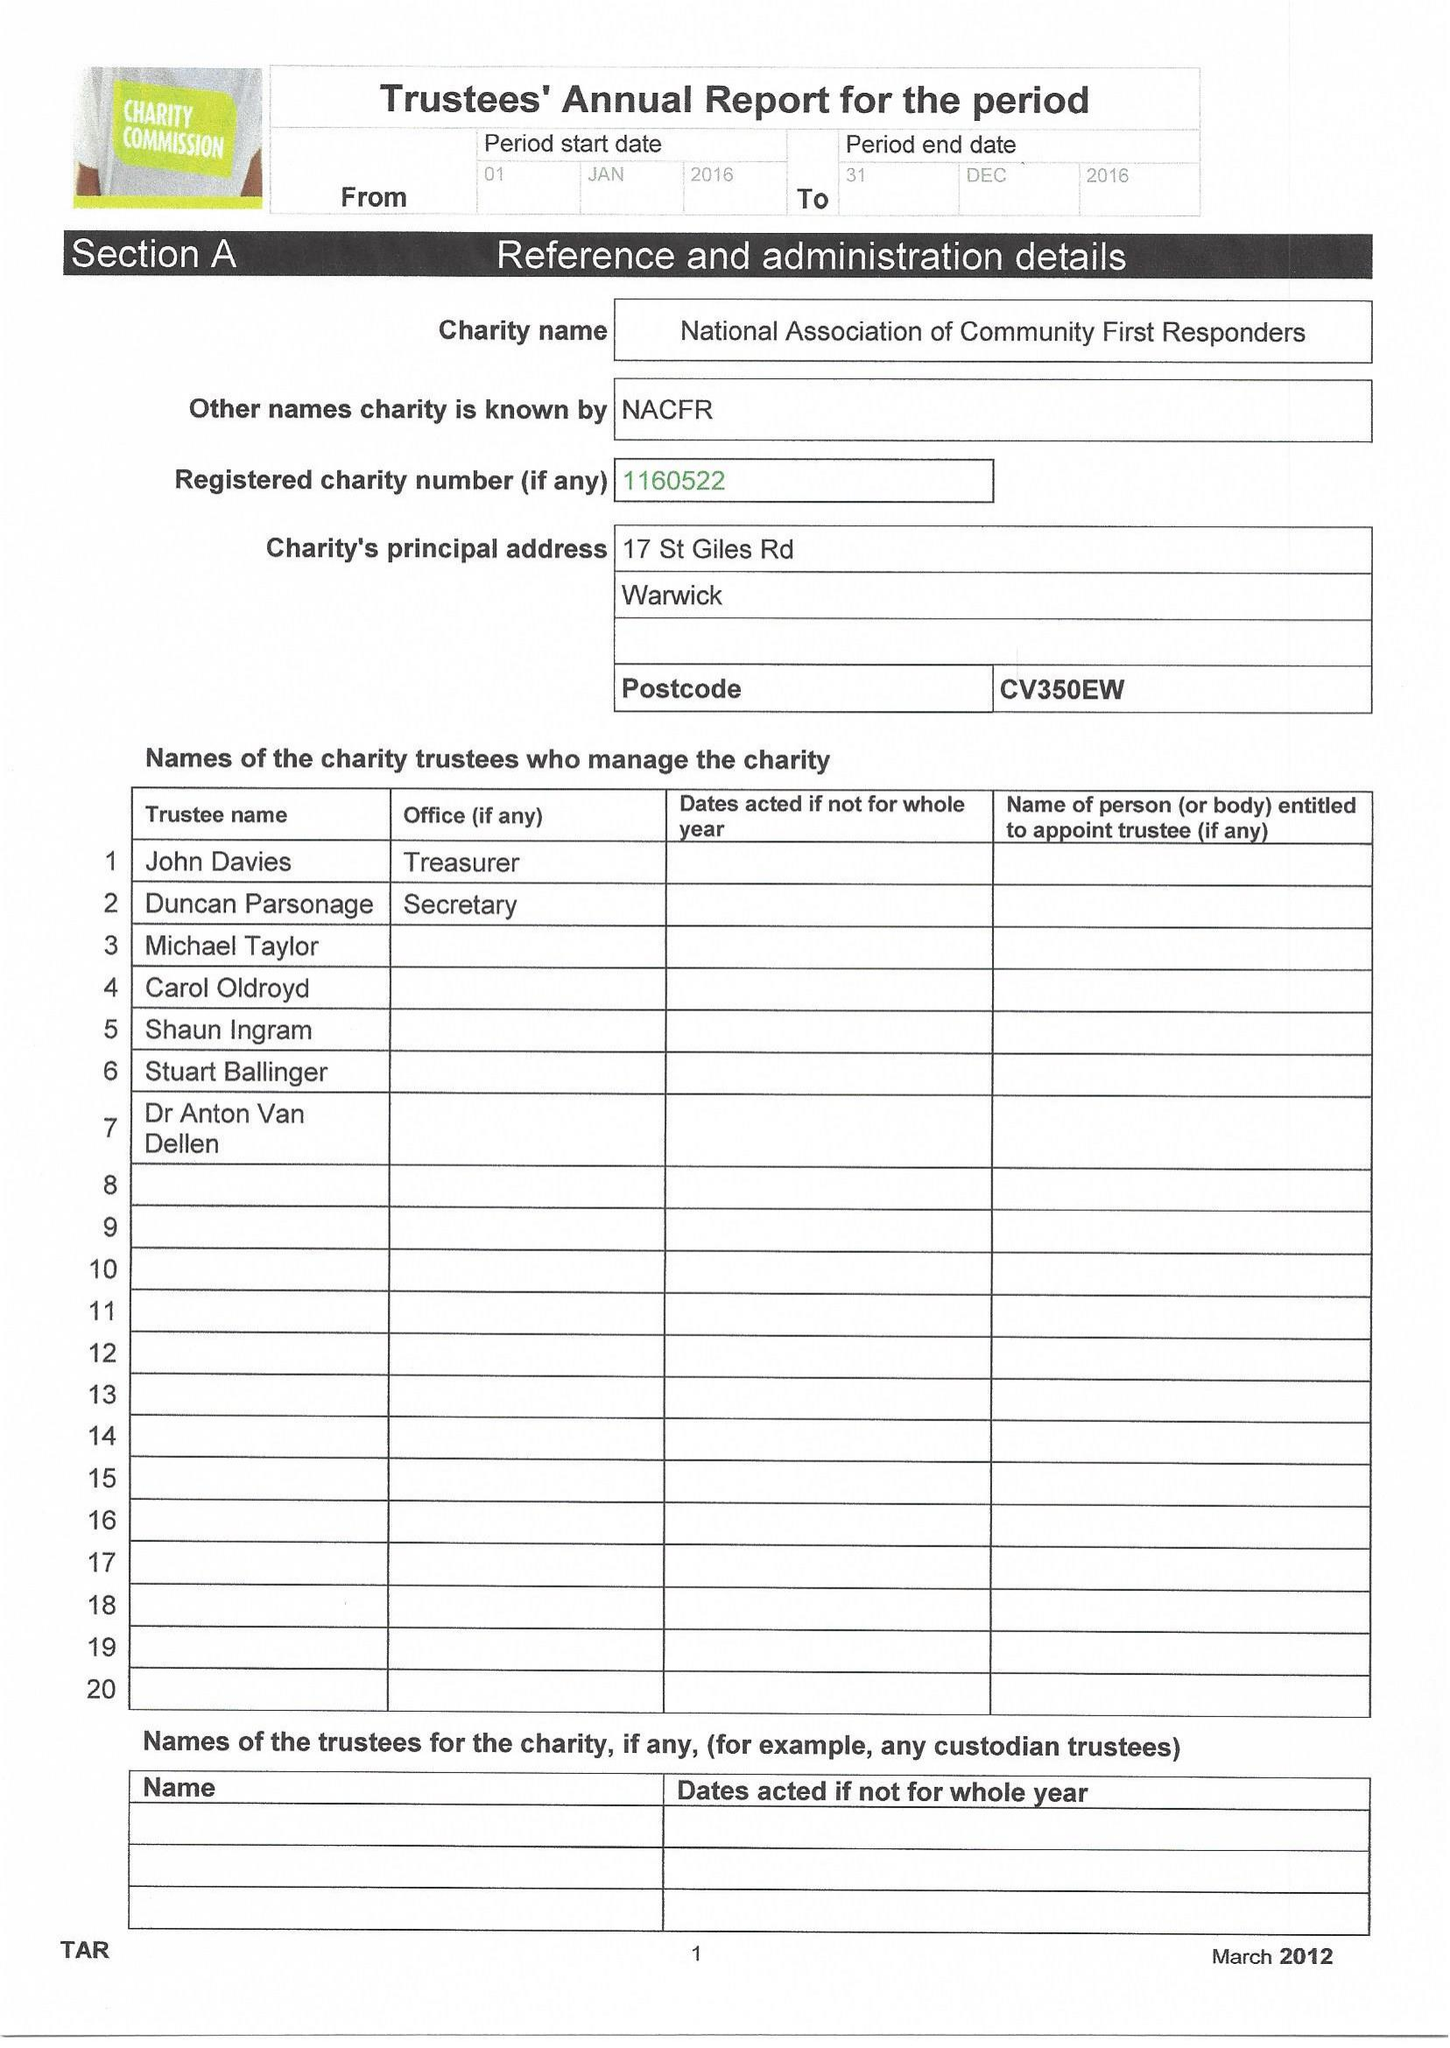What is the value for the address__street_line?
Answer the question using a single word or phrase. WARWICK 